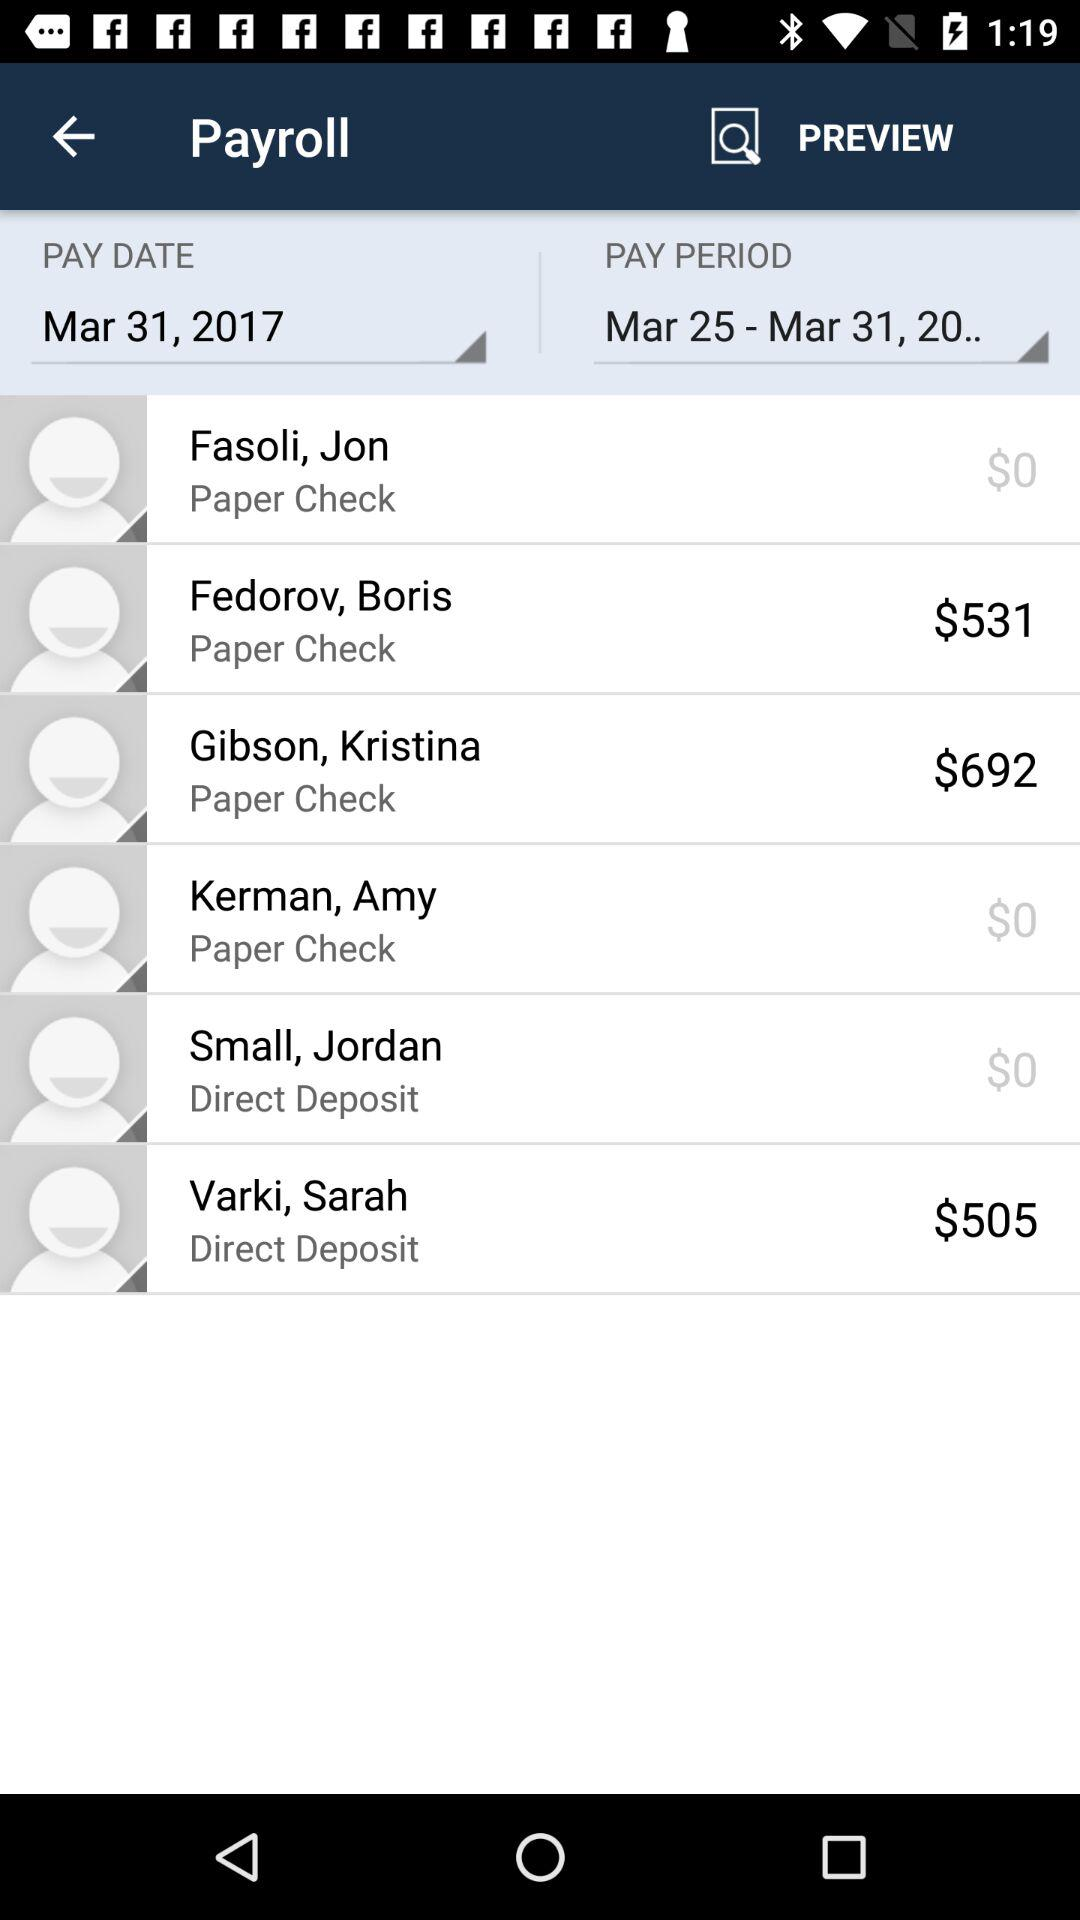How much is paid to Gibson, Kristina? The amount that is paid is $692. 